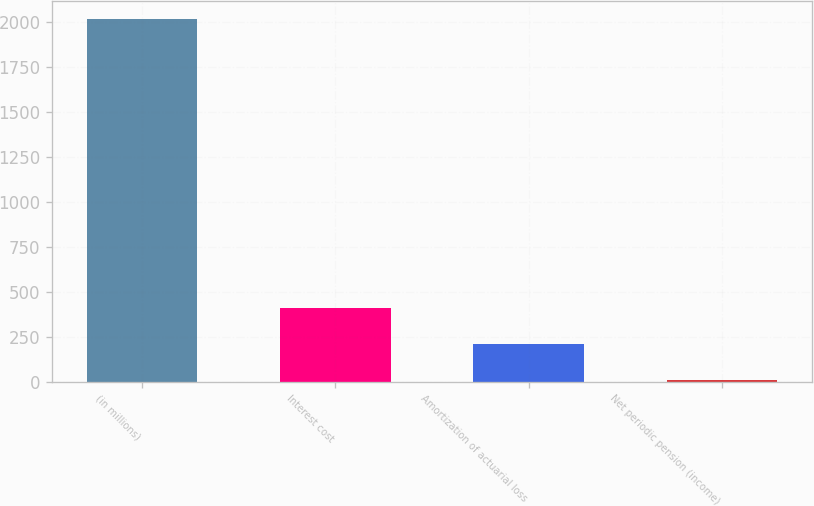Convert chart to OTSL. <chart><loc_0><loc_0><loc_500><loc_500><bar_chart><fcel>(in millions)<fcel>Interest cost<fcel>Amortization of actuarial loss<fcel>Net periodic pension (income)<nl><fcel>2017<fcel>409.8<fcel>208.9<fcel>8<nl></chart> 